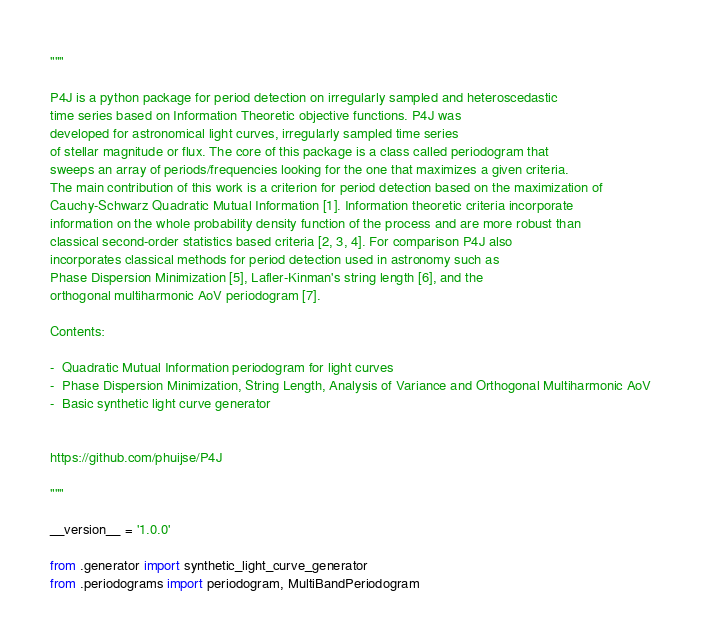<code> <loc_0><loc_0><loc_500><loc_500><_Python_>"""

P4J is a python package for period detection on irregularly sampled and heteroscedastic
time series based on Information Theoretic objective functions. P4J was
developed for astronomical light curves, irregularly sampled time series
of stellar magnitude or flux. The core of this package is a class called periodogram that 
sweeps an array of periods/frequencies looking for the one that maximizes a given criteria. 
The main contribution of this work is a criterion for period detection based on the maximization of
Cauchy-Schwarz Quadratic Mutual Information [1]. Information theoretic criteria incorporate 
information on the whole probability density function of the process and are more robust than 
classical second-order statistics based criteria [2, 3, 4]. For comparison P4J also 
incorporates classical methods for period detection used in astronomy such as
Phase Dispersion Minimization [5], Lafler-Kinman's string length [6], and the 
orthogonal multiharmonic AoV periodogram [7].

Contents:

-  Quadratic Mutual Information periodogram for light curves 
-  Phase Dispersion Minimization, String Length, Analysis of Variance and Orthogonal Multiharmonic AoV
-  Basic synthetic light curve generator


https://github.com/phuijse/P4J

"""

__version__ = '1.0.0'

from .generator import synthetic_light_curve_generator
from .periodograms import periodogram, MultiBandPeriodogram


</code> 